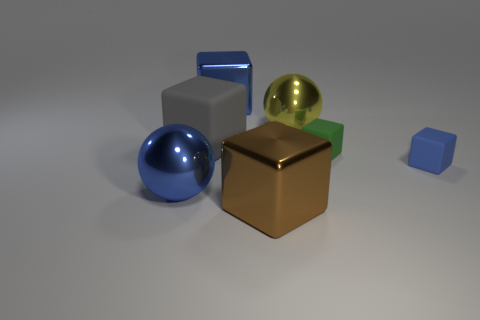Subtract all tiny green blocks. How many blocks are left? 4 Subtract all purple cylinders. How many blue cubes are left? 2 Add 2 gray rubber objects. How many objects exist? 9 Subtract 2 cubes. How many cubes are left? 3 Subtract all brown cubes. How many cubes are left? 4 Subtract all spheres. How many objects are left? 5 Subtract all yellow blocks. Subtract all red spheres. How many blocks are left? 5 Add 7 big brown objects. How many big brown objects exist? 8 Subtract 2 blue blocks. How many objects are left? 5 Subtract all big brown metallic blocks. Subtract all small rubber blocks. How many objects are left? 4 